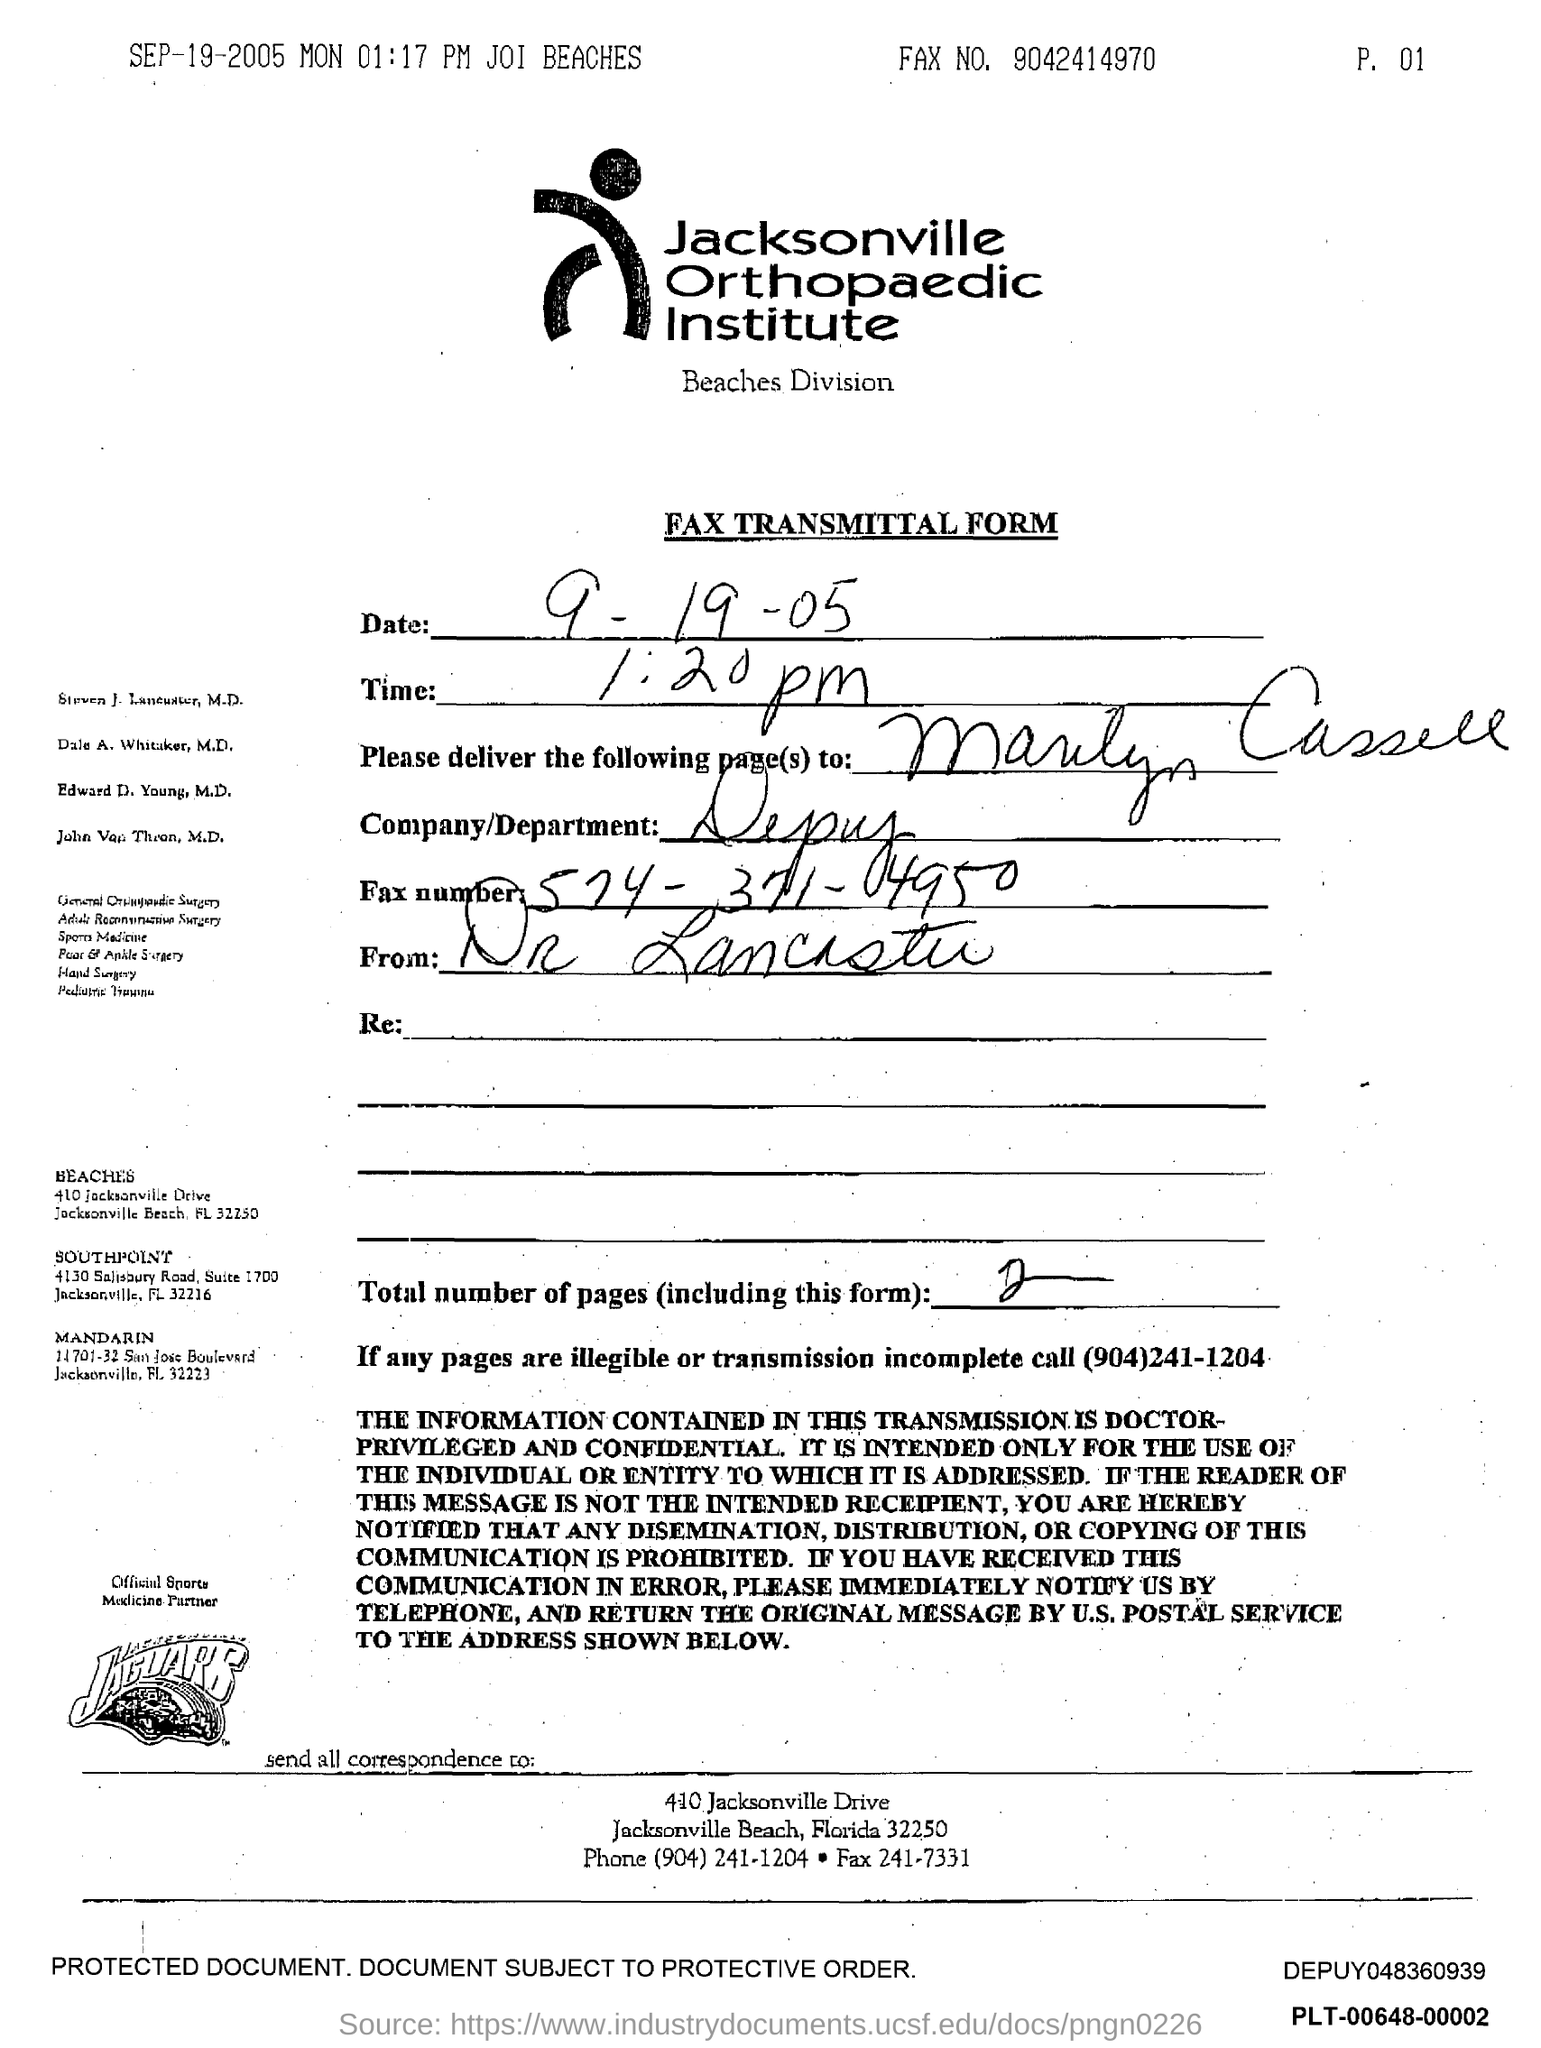What is the Time?
Your answer should be compact. 1:20 pm. What is the Company/Department?
Your answer should be very brief. Depuy. What are the Total Pages?
Give a very brief answer. 2. Which number should be called if any pages are illegible or transmission is incomplete?
Give a very brief answer. (904)241-1204. 